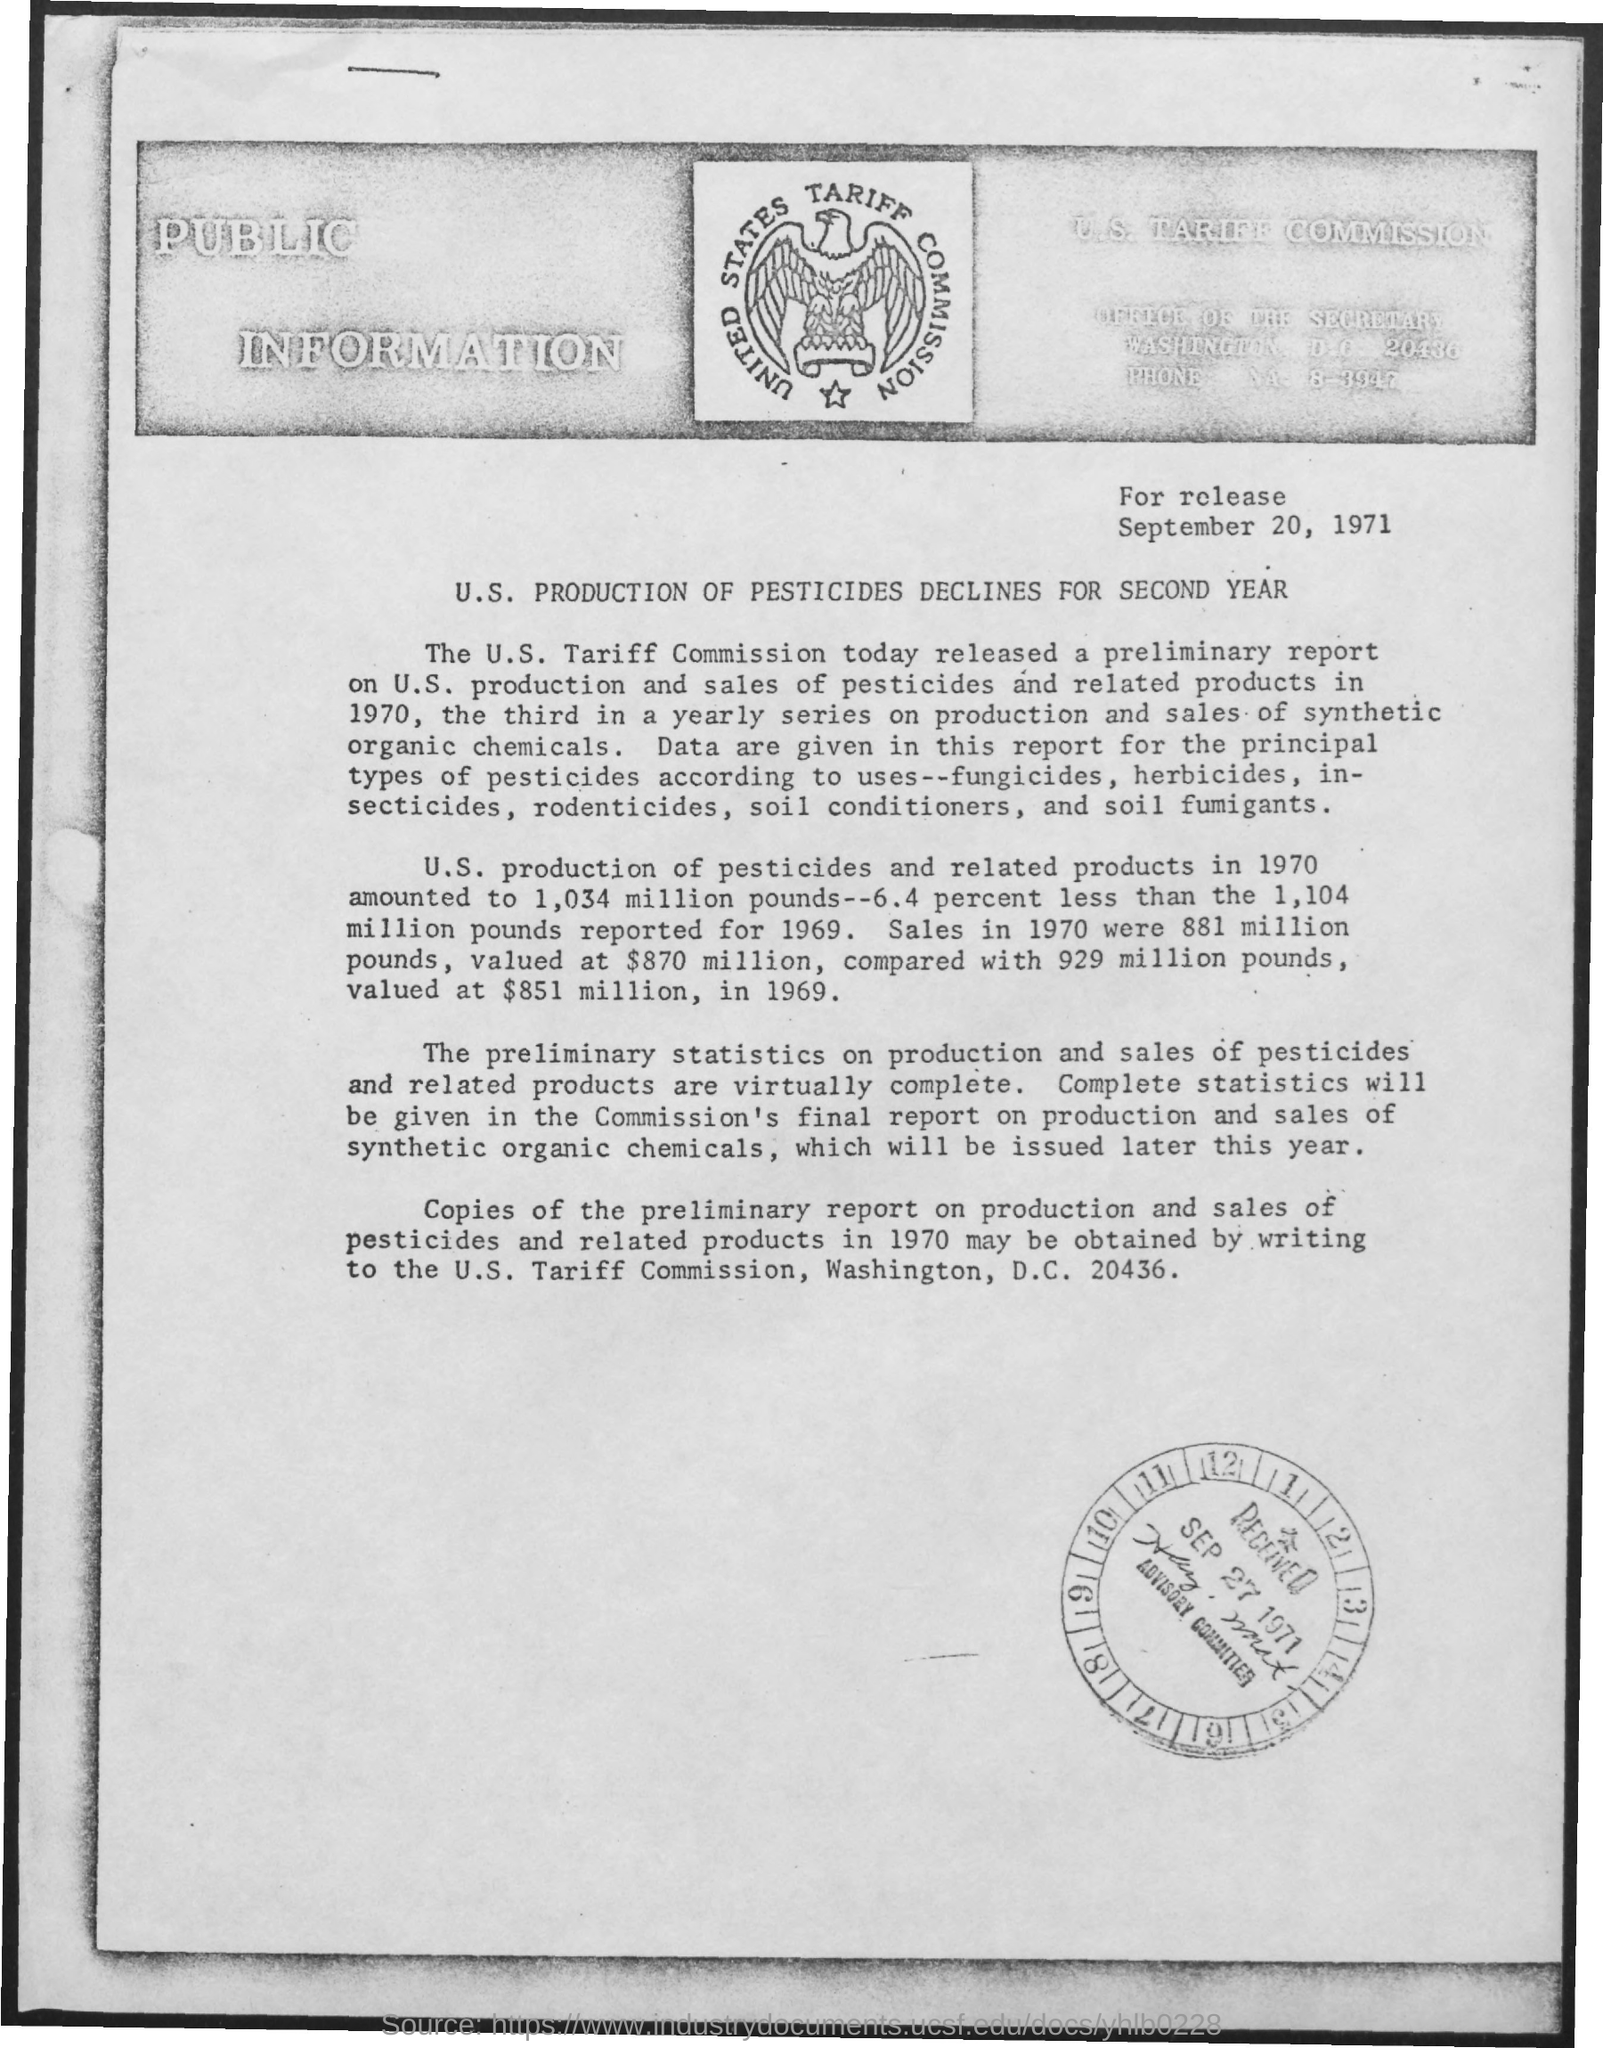What is the received date mentioned ?
Your answer should be compact. Sep 27 1971. What is the date mentioned at the top of the page ?
Your response must be concise. SEPTEMBER 20, 1971. 